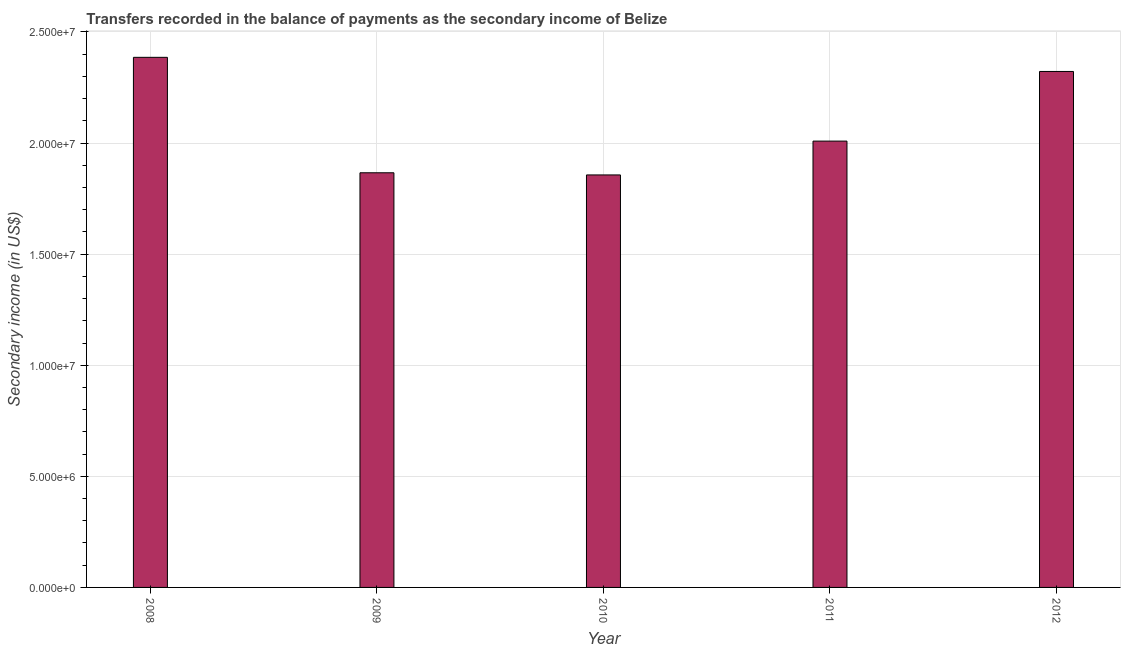Does the graph contain any zero values?
Give a very brief answer. No. What is the title of the graph?
Your answer should be compact. Transfers recorded in the balance of payments as the secondary income of Belize. What is the label or title of the X-axis?
Your answer should be compact. Year. What is the label or title of the Y-axis?
Offer a very short reply. Secondary income (in US$). What is the amount of secondary income in 2011?
Give a very brief answer. 2.01e+07. Across all years, what is the maximum amount of secondary income?
Offer a terse response. 2.39e+07. Across all years, what is the minimum amount of secondary income?
Ensure brevity in your answer.  1.86e+07. In which year was the amount of secondary income maximum?
Your answer should be very brief. 2008. In which year was the amount of secondary income minimum?
Provide a succinct answer. 2010. What is the sum of the amount of secondary income?
Your answer should be compact. 1.04e+08. What is the difference between the amount of secondary income in 2008 and 2009?
Offer a terse response. 5.20e+06. What is the average amount of secondary income per year?
Your answer should be compact. 2.09e+07. What is the median amount of secondary income?
Your response must be concise. 2.01e+07. In how many years, is the amount of secondary income greater than 10000000 US$?
Make the answer very short. 5. Do a majority of the years between 2008 and 2012 (inclusive) have amount of secondary income greater than 11000000 US$?
Ensure brevity in your answer.  Yes. What is the ratio of the amount of secondary income in 2008 to that in 2010?
Provide a short and direct response. 1.28. Is the amount of secondary income in 2010 less than that in 2012?
Ensure brevity in your answer.  Yes. Is the difference between the amount of secondary income in 2009 and 2010 greater than the difference between any two years?
Ensure brevity in your answer.  No. What is the difference between the highest and the second highest amount of secondary income?
Offer a terse response. 6.36e+05. Is the sum of the amount of secondary income in 2009 and 2012 greater than the maximum amount of secondary income across all years?
Your answer should be compact. Yes. What is the difference between the highest and the lowest amount of secondary income?
Your answer should be very brief. 5.29e+06. In how many years, is the amount of secondary income greater than the average amount of secondary income taken over all years?
Give a very brief answer. 2. How many bars are there?
Offer a terse response. 5. Are all the bars in the graph horizontal?
Ensure brevity in your answer.  No. What is the difference between two consecutive major ticks on the Y-axis?
Keep it short and to the point. 5.00e+06. Are the values on the major ticks of Y-axis written in scientific E-notation?
Your answer should be very brief. Yes. What is the Secondary income (in US$) in 2008?
Your answer should be very brief. 2.39e+07. What is the Secondary income (in US$) of 2009?
Provide a short and direct response. 1.87e+07. What is the Secondary income (in US$) in 2010?
Your answer should be very brief. 1.86e+07. What is the Secondary income (in US$) of 2011?
Offer a very short reply. 2.01e+07. What is the Secondary income (in US$) of 2012?
Offer a very short reply. 2.32e+07. What is the difference between the Secondary income (in US$) in 2008 and 2009?
Make the answer very short. 5.20e+06. What is the difference between the Secondary income (in US$) in 2008 and 2010?
Make the answer very short. 5.29e+06. What is the difference between the Secondary income (in US$) in 2008 and 2011?
Offer a very short reply. 3.77e+06. What is the difference between the Secondary income (in US$) in 2008 and 2012?
Provide a short and direct response. 6.36e+05. What is the difference between the Secondary income (in US$) in 2009 and 2010?
Offer a very short reply. 9.71e+04. What is the difference between the Secondary income (in US$) in 2009 and 2011?
Give a very brief answer. -1.43e+06. What is the difference between the Secondary income (in US$) in 2009 and 2012?
Give a very brief answer. -4.56e+06. What is the difference between the Secondary income (in US$) in 2010 and 2011?
Give a very brief answer. -1.52e+06. What is the difference between the Secondary income (in US$) in 2010 and 2012?
Your answer should be very brief. -4.66e+06. What is the difference between the Secondary income (in US$) in 2011 and 2012?
Give a very brief answer. -3.13e+06. What is the ratio of the Secondary income (in US$) in 2008 to that in 2009?
Ensure brevity in your answer.  1.28. What is the ratio of the Secondary income (in US$) in 2008 to that in 2010?
Keep it short and to the point. 1.28. What is the ratio of the Secondary income (in US$) in 2008 to that in 2011?
Your answer should be compact. 1.19. What is the ratio of the Secondary income (in US$) in 2009 to that in 2010?
Offer a terse response. 1. What is the ratio of the Secondary income (in US$) in 2009 to that in 2011?
Offer a very short reply. 0.93. What is the ratio of the Secondary income (in US$) in 2009 to that in 2012?
Provide a succinct answer. 0.8. What is the ratio of the Secondary income (in US$) in 2010 to that in 2011?
Give a very brief answer. 0.92. What is the ratio of the Secondary income (in US$) in 2010 to that in 2012?
Make the answer very short. 0.8. What is the ratio of the Secondary income (in US$) in 2011 to that in 2012?
Make the answer very short. 0.86. 